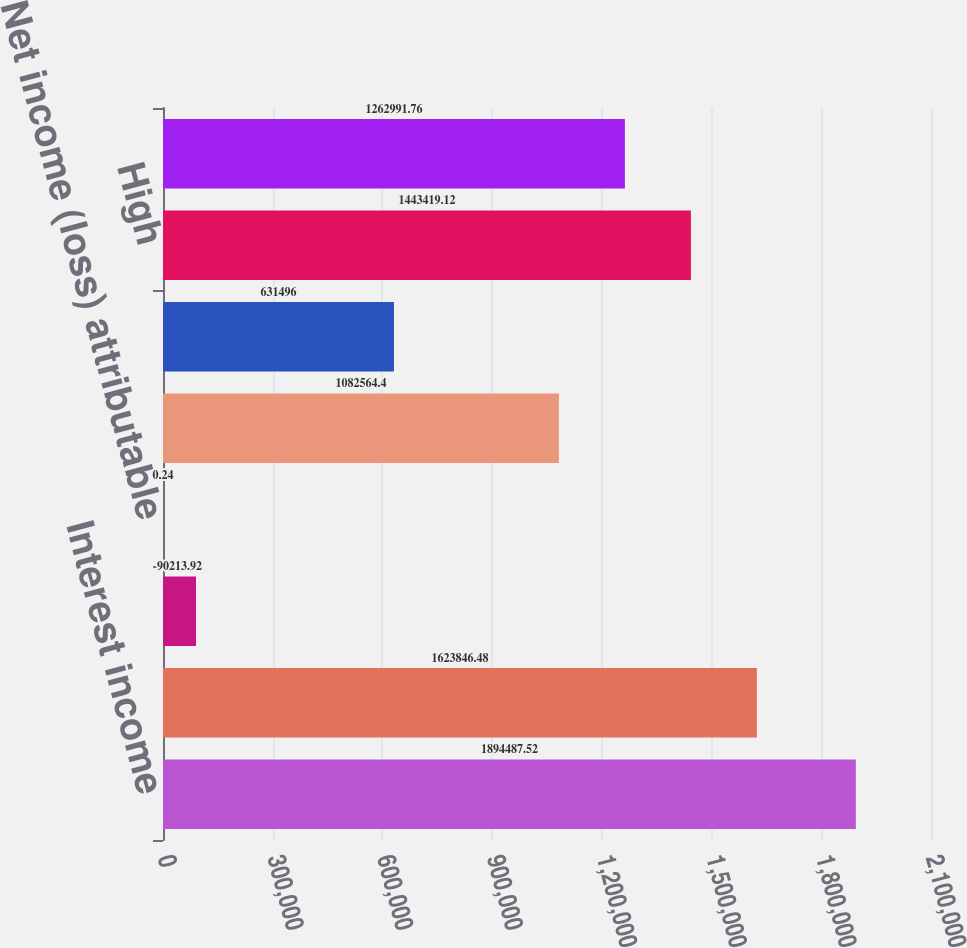Convert chart. <chart><loc_0><loc_0><loc_500><loc_500><bar_chart><fcel>Interest income<fcel>Interest expense<fcel>Income (loss) from continuing<fcel>Net income (loss) attributable<fcel>Tangible book value at period<fcel>Market price<fcel>High<fcel>Low<nl><fcel>1.89449e+06<fcel>1.62385e+06<fcel>90213.9<fcel>0.24<fcel>1.08256e+06<fcel>631496<fcel>1.44342e+06<fcel>1.26299e+06<nl></chart> 